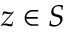<formula> <loc_0><loc_0><loc_500><loc_500>z \in S</formula> 